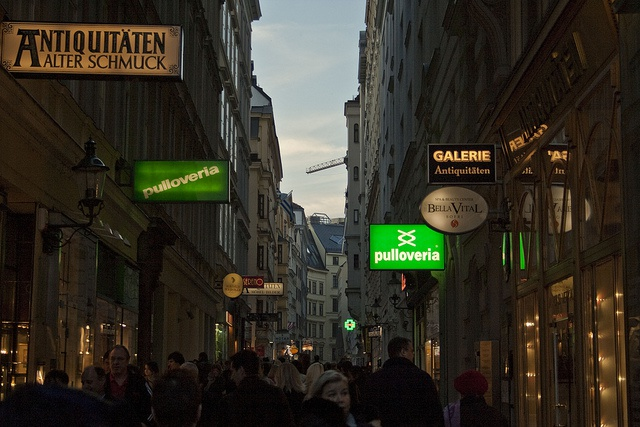Describe the objects in this image and their specific colors. I can see people in black and gray tones, people in black tones, people in black, maroon, and gray tones, people in black tones, and people in black, maroon, and brown tones in this image. 